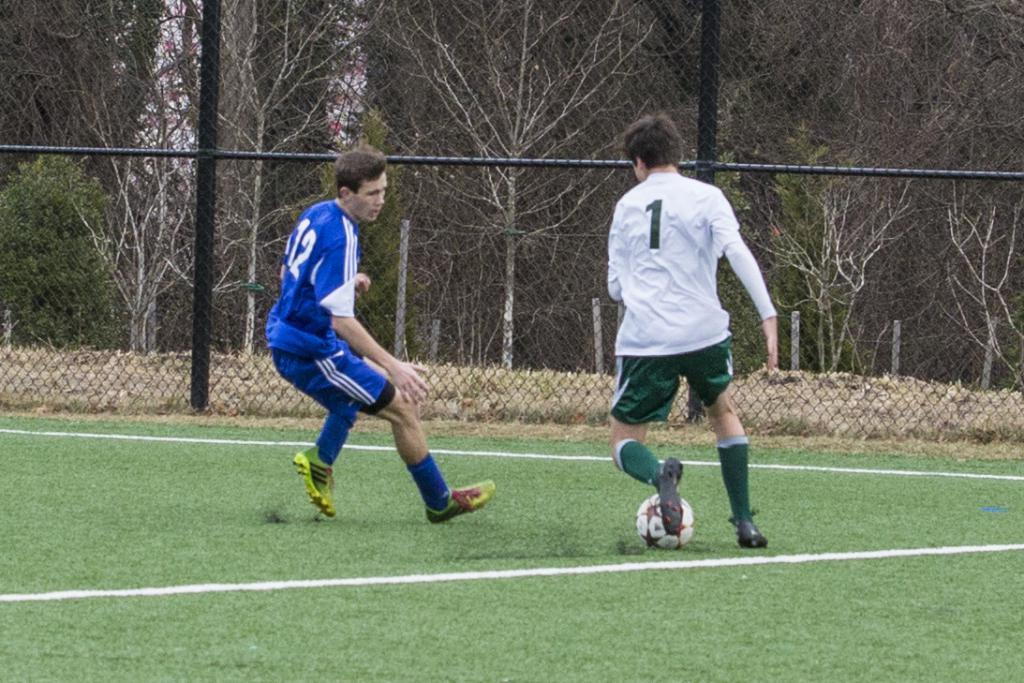What is the player number of the player with the ball?
Give a very brief answer. 1. What number is blue?
Give a very brief answer. 12. 